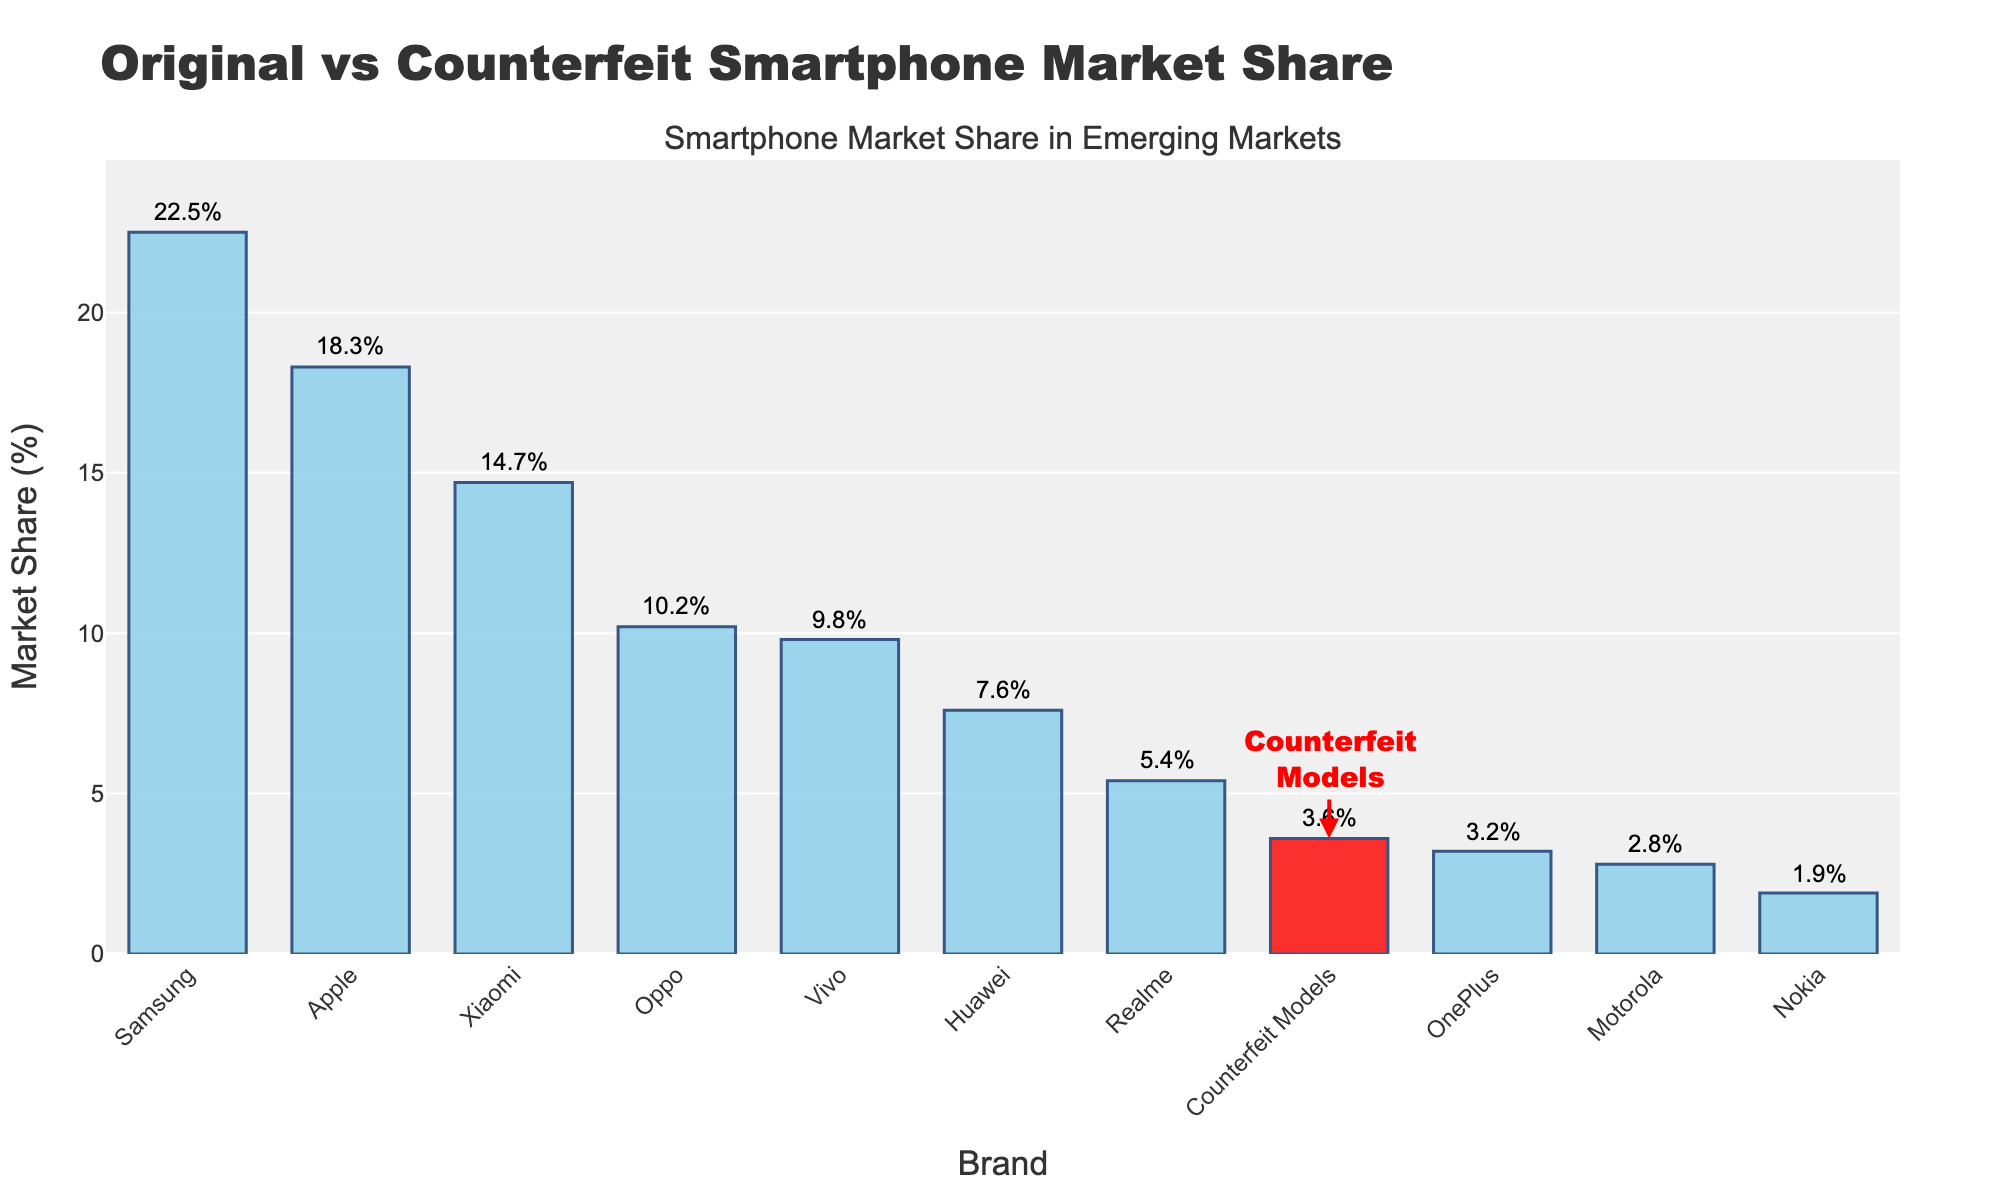What is the market share of Oppo? To find Oppo's market share, look at the corresponding bar and read the percentage value labeled on or near it. The bar for Oppo shows 10.2%.
Answer: 10.2% Which brand has a higher market share, Huawei or Realme? Compare the heights of the bars for Huawei and Realme. Huawei's bar reaches 7.6% while Realme's bar reaches 5.4%. Therefore, Huawei has a higher market share than Realme.
Answer: Huawei What is the combined market share of Nokia and Motorola? Add the market shares of Nokia and Motorola by locating their respective bars. Nokia has 1.9% and Motorola has 2.8%. Summing these values gives 1.9% + 2.8% = 4.7%.
Answer: 4.7% What is the color of the bar representing counterfeit models? Identify the bar labeled "Counterfeit Models" and note its color. The bar for counterfeit models is colored red.
Answer: Red How much higher is Samsung's market share compared to Apple's? Subtract Apple's market share from Samsung's. Samsung has 22.5% and Apple has 18.3%. The difference is 22.5% - 18.3% = 4.2%.
Answer: 4.2% Which brands have market shares greater than 10%? Look for bars with values above 10%. Samsung (22.5%), Apple (18.3%), Xiaomi (14.7%), Oppo (10.2%), and Vivo (9.8%) qualify. Therefore, Samsung, Apple, Xiaomi, and Oppo have market shares greater than 10%.
Answer: Samsung, Apple, Xiaomi, Oppo What is the average market share of the brands listed? Sum all the percentages and divide by the number of brands. The sum is 22.5 + 18.3 + 14.7 + 10.2 + 9.8 + 7.6 + 5.4 + 3.2 + 2.8 + 1.9 = 96.4. Divide by 10 to get the average, which is 96.4 / 10 = 9.64%.
Answer: 9.64% Is the market share of counterfeit models higher or lower than that of OnePlus? Compare the bars for counterfeit models and OnePlus. The bar for counterfeit models shows a market share of 3.6%, and the bar for OnePlus shows 3.2%. Therefore, the market share of counterfeit models is higher than OnePlus.
Answer: Higher 